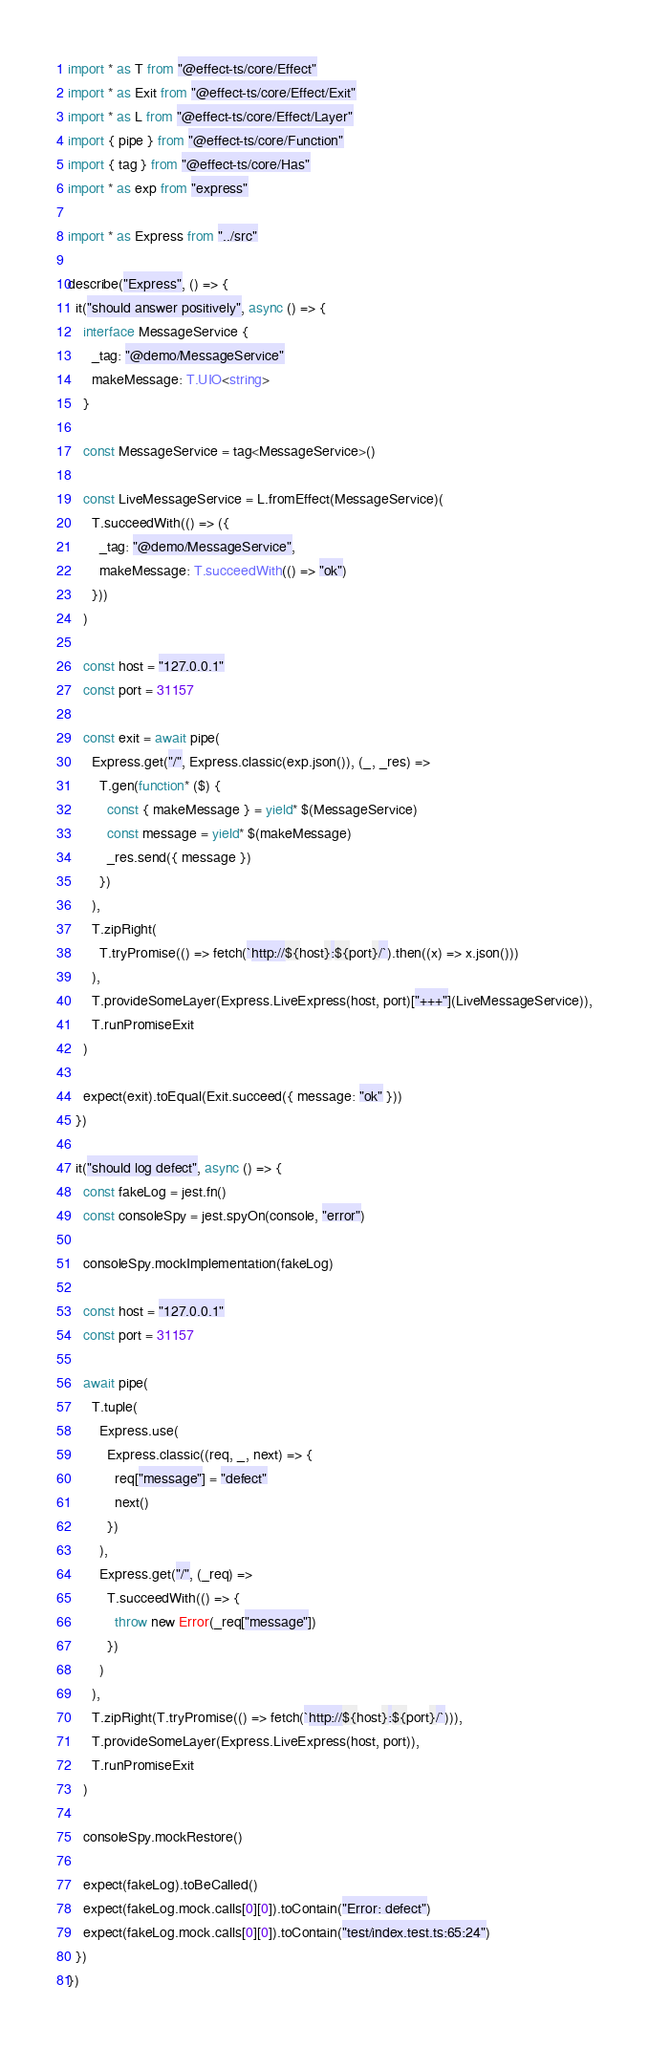Convert code to text. <code><loc_0><loc_0><loc_500><loc_500><_TypeScript_>import * as T from "@effect-ts/core/Effect"
import * as Exit from "@effect-ts/core/Effect/Exit"
import * as L from "@effect-ts/core/Effect/Layer"
import { pipe } from "@effect-ts/core/Function"
import { tag } from "@effect-ts/core/Has"
import * as exp from "express"

import * as Express from "../src"

describe("Express", () => {
  it("should answer positively", async () => {
    interface MessageService {
      _tag: "@demo/MessageService"
      makeMessage: T.UIO<string>
    }

    const MessageService = tag<MessageService>()

    const LiveMessageService = L.fromEffect(MessageService)(
      T.succeedWith(() => ({
        _tag: "@demo/MessageService",
        makeMessage: T.succeedWith(() => "ok")
      }))
    )

    const host = "127.0.0.1"
    const port = 31157

    const exit = await pipe(
      Express.get("/", Express.classic(exp.json()), (_, _res) =>
        T.gen(function* ($) {
          const { makeMessage } = yield* $(MessageService)
          const message = yield* $(makeMessage)
          _res.send({ message })
        })
      ),
      T.zipRight(
        T.tryPromise(() => fetch(`http://${host}:${port}/`).then((x) => x.json()))
      ),
      T.provideSomeLayer(Express.LiveExpress(host, port)["+++"](LiveMessageService)),
      T.runPromiseExit
    )

    expect(exit).toEqual(Exit.succeed({ message: "ok" }))
  })

  it("should log defect", async () => {
    const fakeLog = jest.fn()
    const consoleSpy = jest.spyOn(console, "error")

    consoleSpy.mockImplementation(fakeLog)

    const host = "127.0.0.1"
    const port = 31157

    await pipe(
      T.tuple(
        Express.use(
          Express.classic((req, _, next) => {
            req["message"] = "defect"
            next()
          })
        ),
        Express.get("/", (_req) =>
          T.succeedWith(() => {
            throw new Error(_req["message"])
          })
        )
      ),
      T.zipRight(T.tryPromise(() => fetch(`http://${host}:${port}/`))),
      T.provideSomeLayer(Express.LiveExpress(host, port)),
      T.runPromiseExit
    )

    consoleSpy.mockRestore()

    expect(fakeLog).toBeCalled()
    expect(fakeLog.mock.calls[0][0]).toContain("Error: defect")
    expect(fakeLog.mock.calls[0][0]).toContain("test/index.test.ts:65:24")
  })
})
</code> 